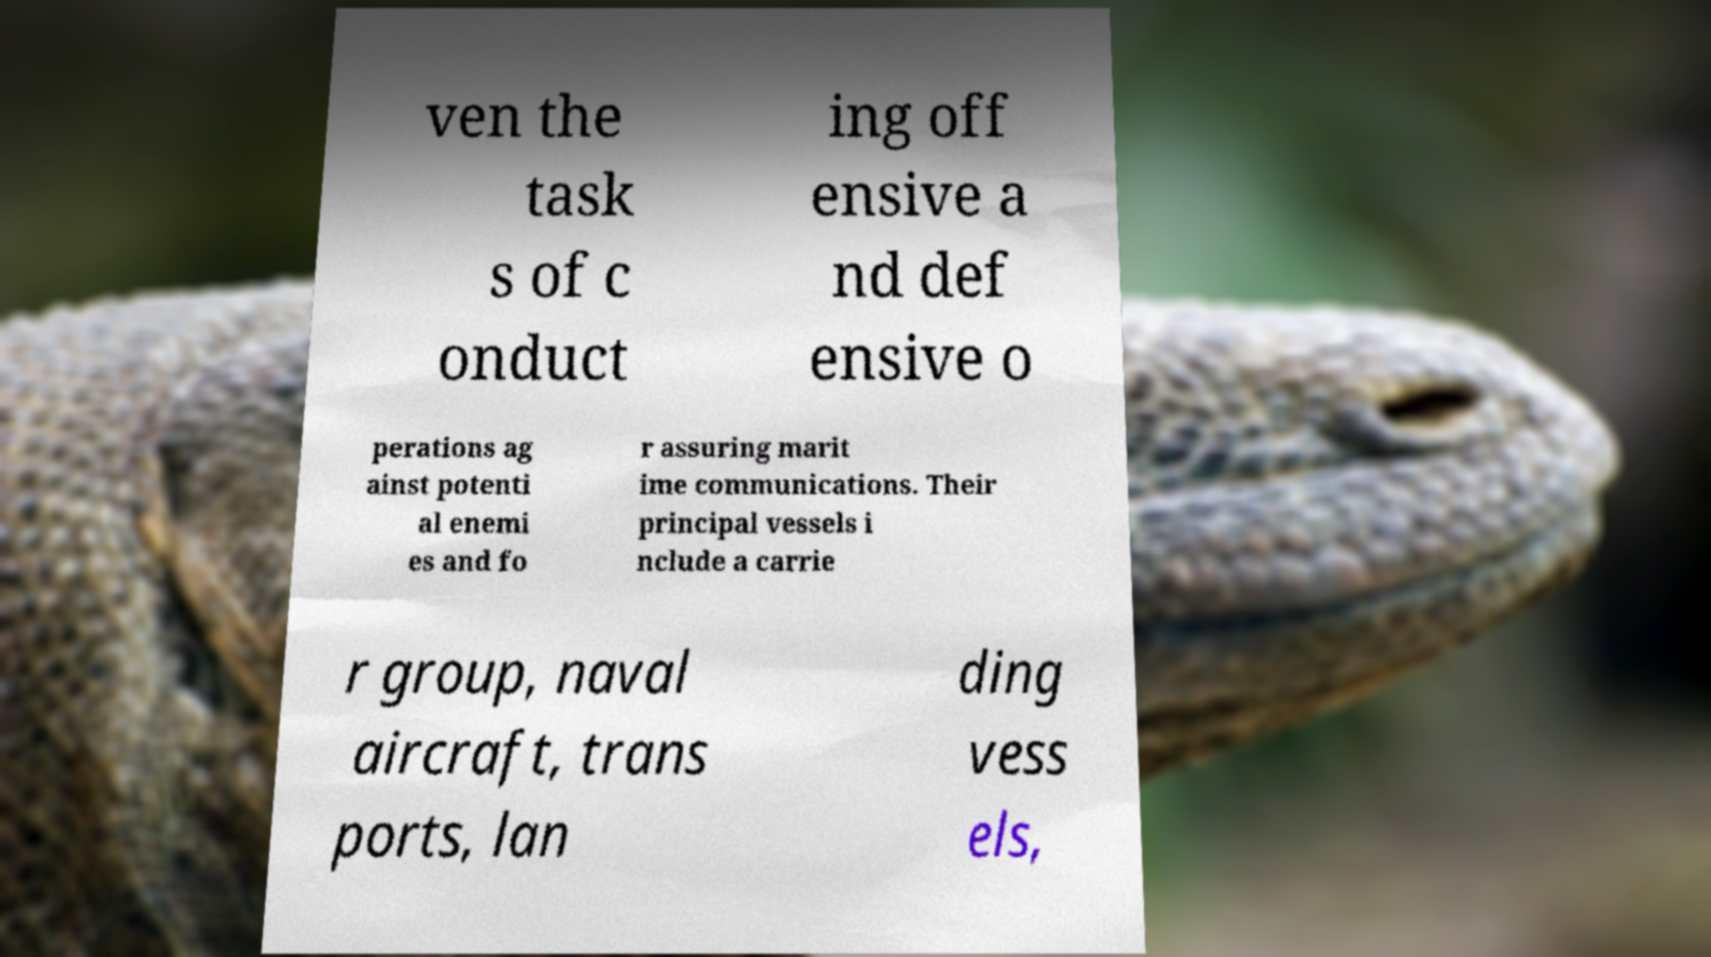I need the written content from this picture converted into text. Can you do that? ven the task s of c onduct ing off ensive a nd def ensive o perations ag ainst potenti al enemi es and fo r assuring marit ime communications. Their principal vessels i nclude a carrie r group, naval aircraft, trans ports, lan ding vess els, 